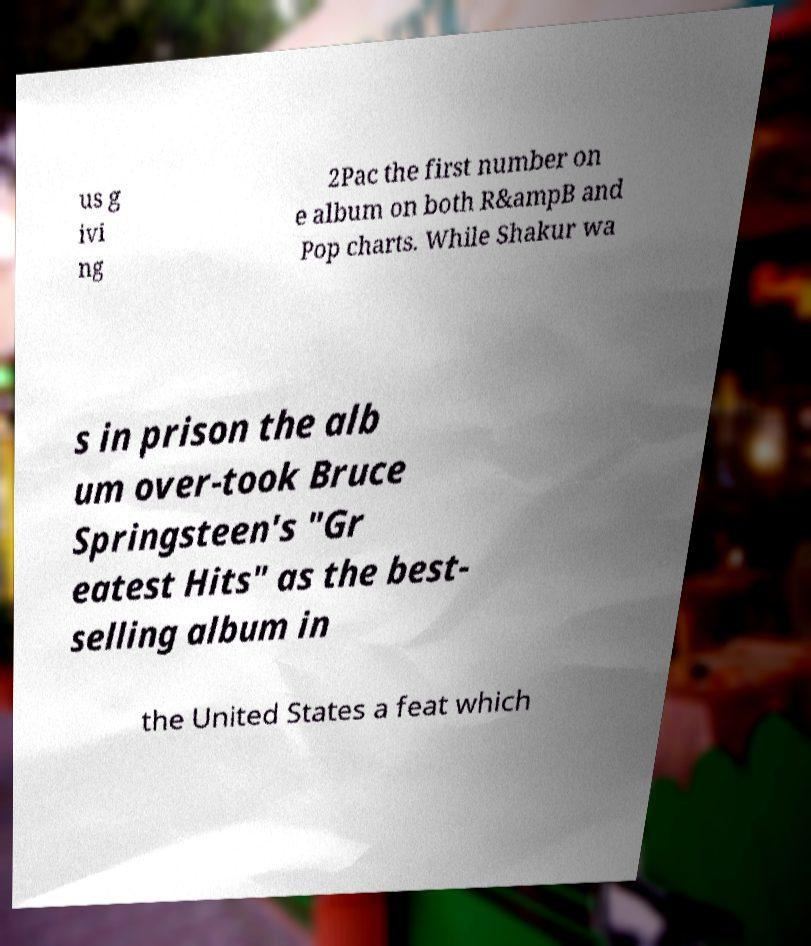Can you read and provide the text displayed in the image?This photo seems to have some interesting text. Can you extract and type it out for me? us g ivi ng 2Pac the first number on e album on both R&ampB and Pop charts. While Shakur wa s in prison the alb um over-took Bruce Springsteen's "Gr eatest Hits" as the best- selling album in the United States a feat which 